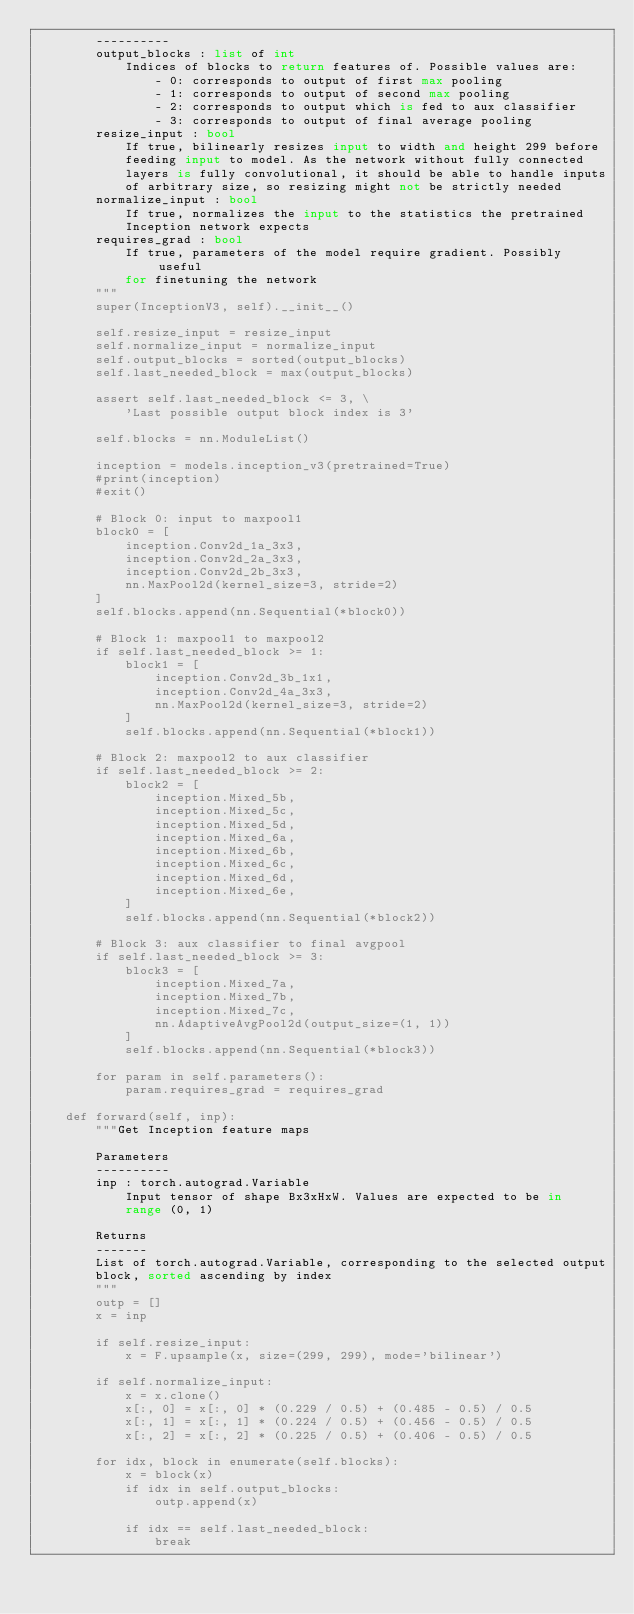<code> <loc_0><loc_0><loc_500><loc_500><_Python_>        ----------
        output_blocks : list of int
            Indices of blocks to return features of. Possible values are:
                - 0: corresponds to output of first max pooling
                - 1: corresponds to output of second max pooling
                - 2: corresponds to output which is fed to aux classifier
                - 3: corresponds to output of final average pooling
        resize_input : bool
            If true, bilinearly resizes input to width and height 299 before
            feeding input to model. As the network without fully connected
            layers is fully convolutional, it should be able to handle inputs
            of arbitrary size, so resizing might not be strictly needed
        normalize_input : bool
            If true, normalizes the input to the statistics the pretrained
            Inception network expects
        requires_grad : bool
            If true, parameters of the model require gradient. Possibly useful
            for finetuning the network
        """
        super(InceptionV3, self).__init__()

        self.resize_input = resize_input
        self.normalize_input = normalize_input
        self.output_blocks = sorted(output_blocks)
        self.last_needed_block = max(output_blocks)

        assert self.last_needed_block <= 3, \
            'Last possible output block index is 3'

        self.blocks = nn.ModuleList()

        inception = models.inception_v3(pretrained=True)
        #print(inception)
        #exit()

        # Block 0: input to maxpool1
        block0 = [
            inception.Conv2d_1a_3x3,
            inception.Conv2d_2a_3x3,
            inception.Conv2d_2b_3x3,
            nn.MaxPool2d(kernel_size=3, stride=2)
        ]
        self.blocks.append(nn.Sequential(*block0))

        # Block 1: maxpool1 to maxpool2
        if self.last_needed_block >= 1:
            block1 = [
                inception.Conv2d_3b_1x1,
                inception.Conv2d_4a_3x3,
                nn.MaxPool2d(kernel_size=3, stride=2)
            ]
            self.blocks.append(nn.Sequential(*block1))

        # Block 2: maxpool2 to aux classifier
        if self.last_needed_block >= 2:
            block2 = [
                inception.Mixed_5b,
                inception.Mixed_5c,
                inception.Mixed_5d,
                inception.Mixed_6a,
                inception.Mixed_6b,
                inception.Mixed_6c,
                inception.Mixed_6d,
                inception.Mixed_6e,
            ]
            self.blocks.append(nn.Sequential(*block2))

        # Block 3: aux classifier to final avgpool
        if self.last_needed_block >= 3:
            block3 = [
                inception.Mixed_7a,
                inception.Mixed_7b,
                inception.Mixed_7c,
                nn.AdaptiveAvgPool2d(output_size=(1, 1))
            ]
            self.blocks.append(nn.Sequential(*block3))

        for param in self.parameters():
            param.requires_grad = requires_grad

    def forward(self, inp):
        """Get Inception feature maps

        Parameters
        ----------
        inp : torch.autograd.Variable
            Input tensor of shape Bx3xHxW. Values are expected to be in 
            range (0, 1)

        Returns
        -------
        List of torch.autograd.Variable, corresponding to the selected output 
        block, sorted ascending by index
        """
        outp = []
        x = inp

        if self.resize_input:
            x = F.upsample(x, size=(299, 299), mode='bilinear')

        if self.normalize_input:
            x = x.clone()
            x[:, 0] = x[:, 0] * (0.229 / 0.5) + (0.485 - 0.5) / 0.5
            x[:, 1] = x[:, 1] * (0.224 / 0.5) + (0.456 - 0.5) / 0.5
            x[:, 2] = x[:, 2] * (0.225 / 0.5) + (0.406 - 0.5) / 0.5

        for idx, block in enumerate(self.blocks):
            x = block(x)
            if idx in self.output_blocks:
                outp.append(x)

            if idx == self.last_needed_block:
                break
</code> 